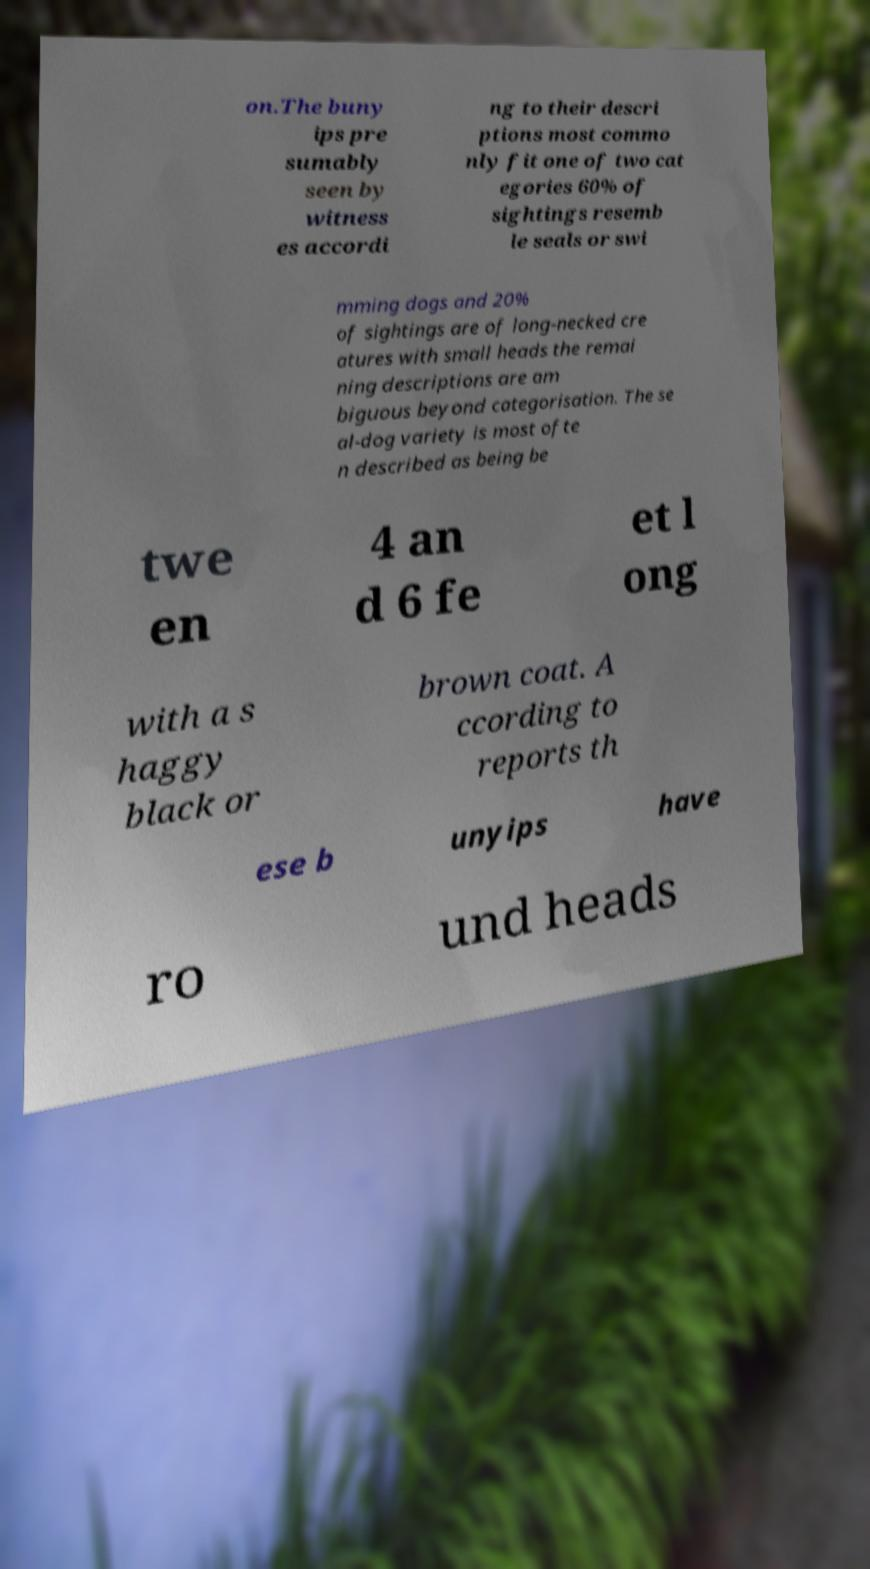Please identify and transcribe the text found in this image. on.The buny ips pre sumably seen by witness es accordi ng to their descri ptions most commo nly fit one of two cat egories 60% of sightings resemb le seals or swi mming dogs and 20% of sightings are of long-necked cre atures with small heads the remai ning descriptions are am biguous beyond categorisation. The se al-dog variety is most ofte n described as being be twe en 4 an d 6 fe et l ong with a s haggy black or brown coat. A ccording to reports th ese b unyips have ro und heads 